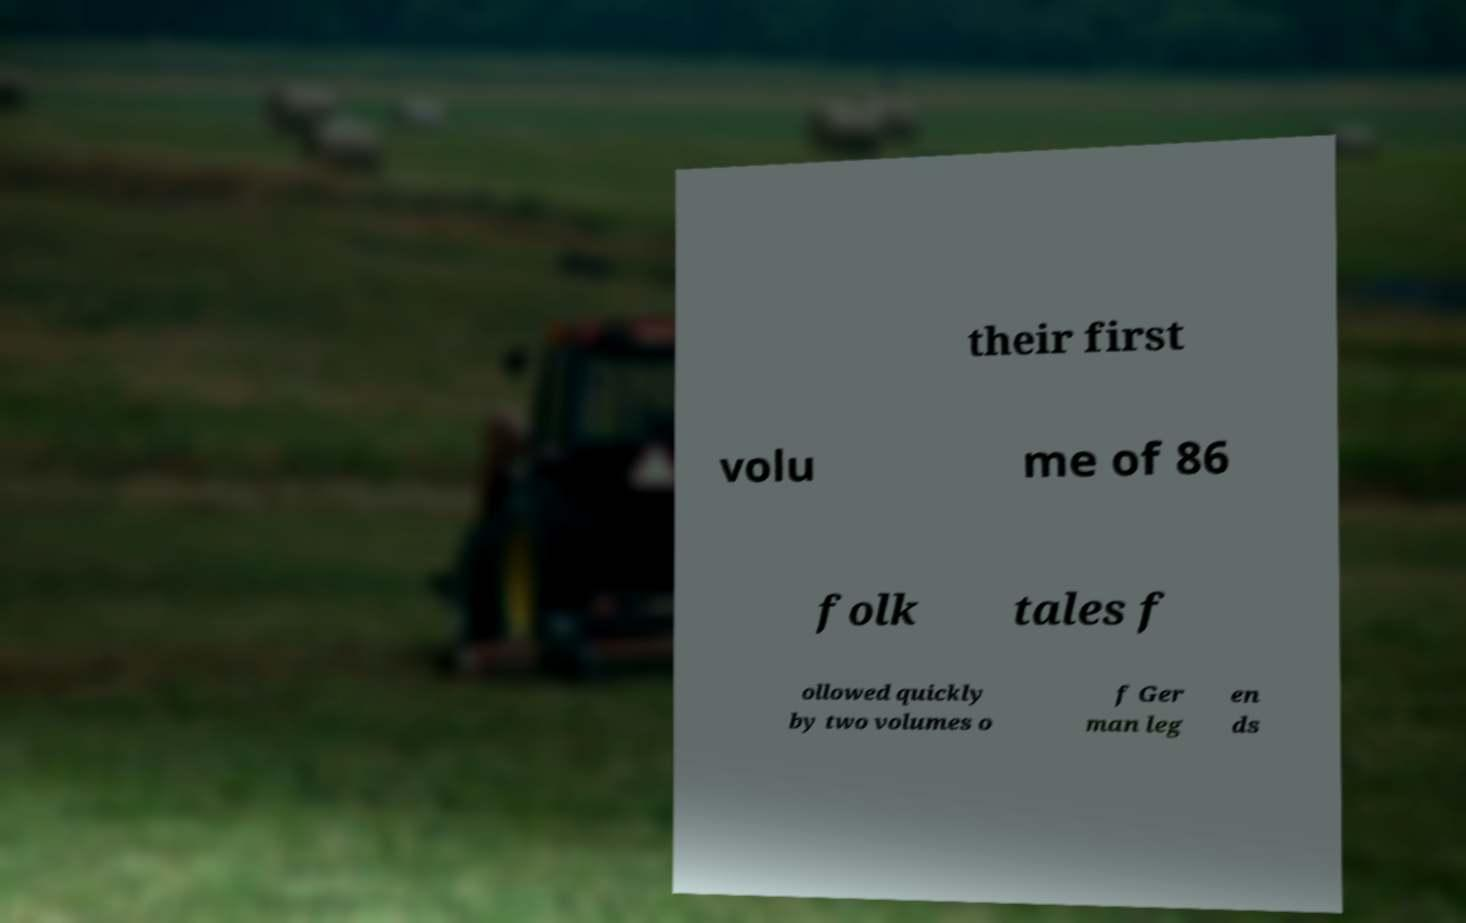Could you assist in decoding the text presented in this image and type it out clearly? their first volu me of 86 folk tales f ollowed quickly by two volumes o f Ger man leg en ds 